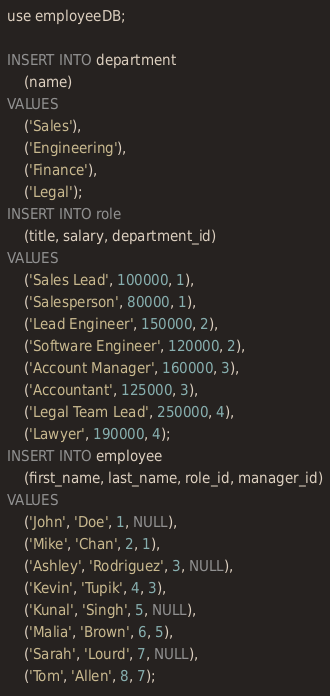<code> <loc_0><loc_0><loc_500><loc_500><_SQL_>use employeeDB;

INSERT INTO department
    (name)
VALUES
    ('Sales'),
    ('Engineering'),
    ('Finance'),
    ('Legal');
INSERT INTO role
    (title, salary, department_id)
VALUES
    ('Sales Lead', 100000, 1),
    ('Salesperson', 80000, 1),
    ('Lead Engineer', 150000, 2),
    ('Software Engineer', 120000, 2),
    ('Account Manager', 160000, 3),
    ('Accountant', 125000, 3),
    ('Legal Team Lead', 250000, 4),
    ('Lawyer', 190000, 4);
INSERT INTO employee
    (first_name, last_name, role_id, manager_id)
VALUES
    ('John', 'Doe', 1, NULL),
    ('Mike', 'Chan', 2, 1),
    ('Ashley', 'Rodriguez', 3, NULL),
    ('Kevin', 'Tupik', 4, 3),
    ('Kunal', 'Singh', 5, NULL),
    ('Malia', 'Brown', 6, 5),
    ('Sarah', 'Lourd', 7, NULL),
    ('Tom', 'Allen', 8, 7);</code> 